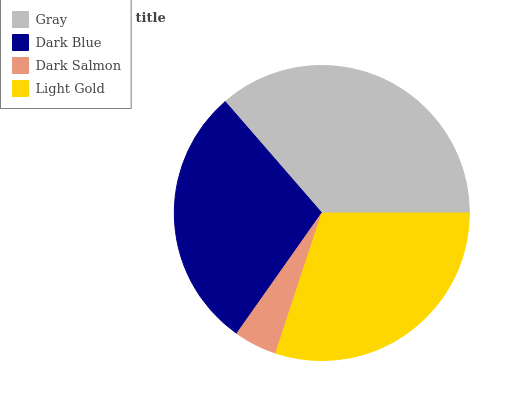Is Dark Salmon the minimum?
Answer yes or no. Yes. Is Gray the maximum?
Answer yes or no. Yes. Is Dark Blue the minimum?
Answer yes or no. No. Is Dark Blue the maximum?
Answer yes or no. No. Is Gray greater than Dark Blue?
Answer yes or no. Yes. Is Dark Blue less than Gray?
Answer yes or no. Yes. Is Dark Blue greater than Gray?
Answer yes or no. No. Is Gray less than Dark Blue?
Answer yes or no. No. Is Light Gold the high median?
Answer yes or no. Yes. Is Dark Blue the low median?
Answer yes or no. Yes. Is Dark Salmon the high median?
Answer yes or no. No. Is Dark Salmon the low median?
Answer yes or no. No. 